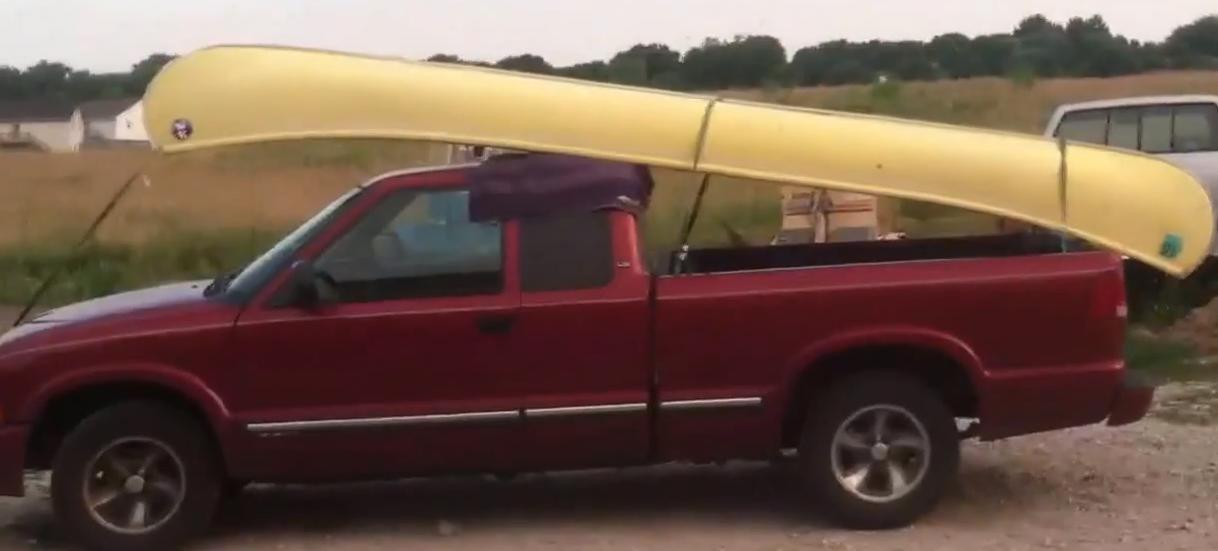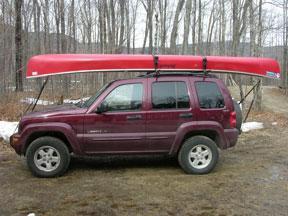The first image is the image on the left, the second image is the image on the right. Evaluate the accuracy of this statement regarding the images: "A vehicle in one image is loaded with more than one boat.". Is it true? Answer yes or no. No. 